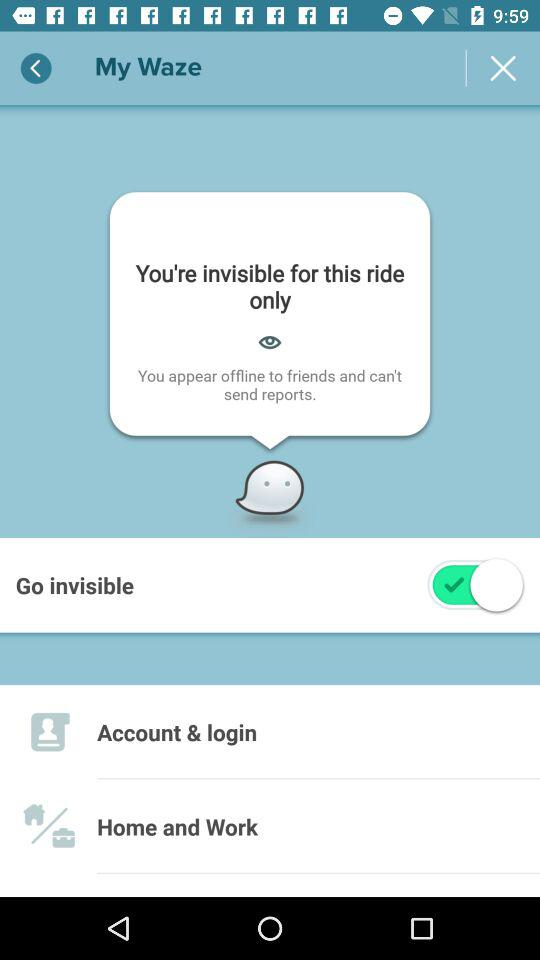What is the status of the go invisible setting? The status is on. 